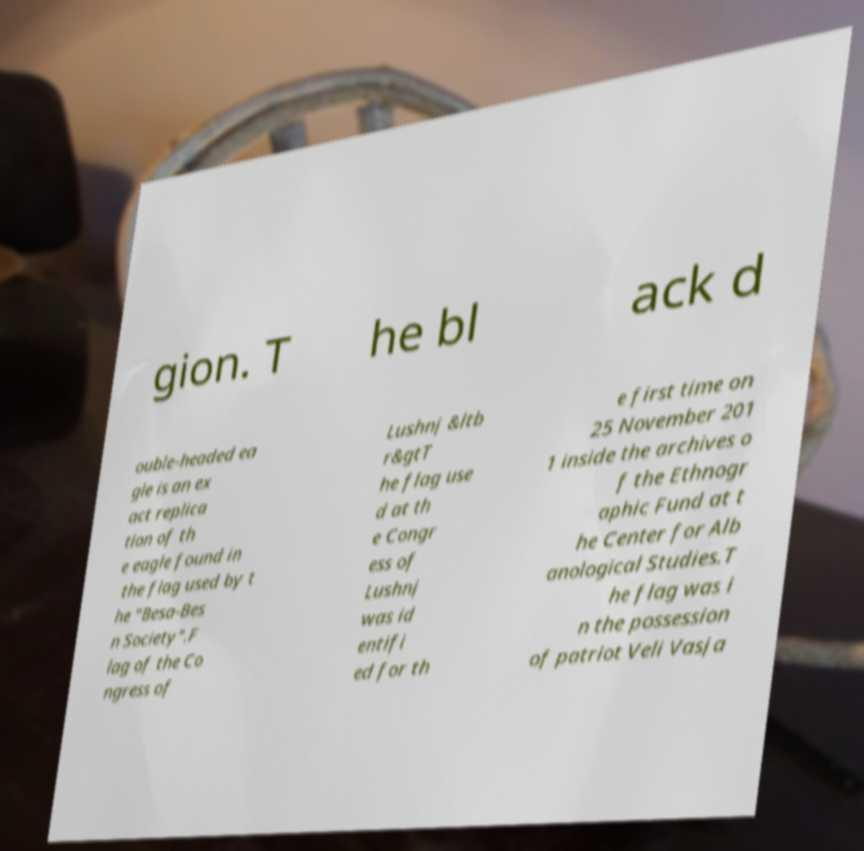I need the written content from this picture converted into text. Can you do that? gion. T he bl ack d ouble-headed ea gle is an ex act replica tion of th e eagle found in the flag used by t he "Besa-Bes n Society".F lag of the Co ngress of Lushnj &ltb r&gtT he flag use d at th e Congr ess of Lushnj was id entifi ed for th e first time on 25 November 201 1 inside the archives o f the Ethnogr aphic Fund at t he Center for Alb anological Studies.T he flag was i n the possession of patriot Veli Vasja 